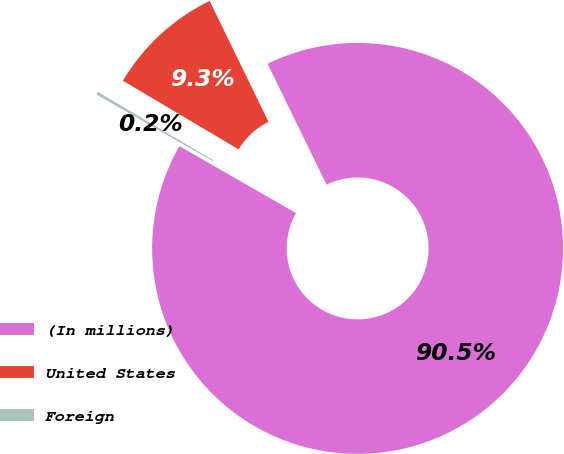Convert chart to OTSL. <chart><loc_0><loc_0><loc_500><loc_500><pie_chart><fcel>(In millions)<fcel>United States<fcel>Foreign<nl><fcel>90.52%<fcel>9.26%<fcel>0.23%<nl></chart> 